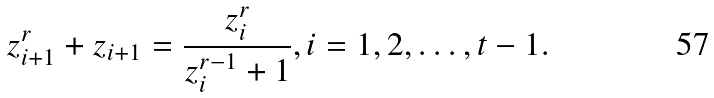<formula> <loc_0><loc_0><loc_500><loc_500>z _ { i + 1 } ^ { r } + z _ { i + 1 } = \frac { z _ { i } ^ { r } } { z _ { i } ^ { r - 1 } + 1 } , i = 1 , 2 , \dots , t - 1 .</formula> 